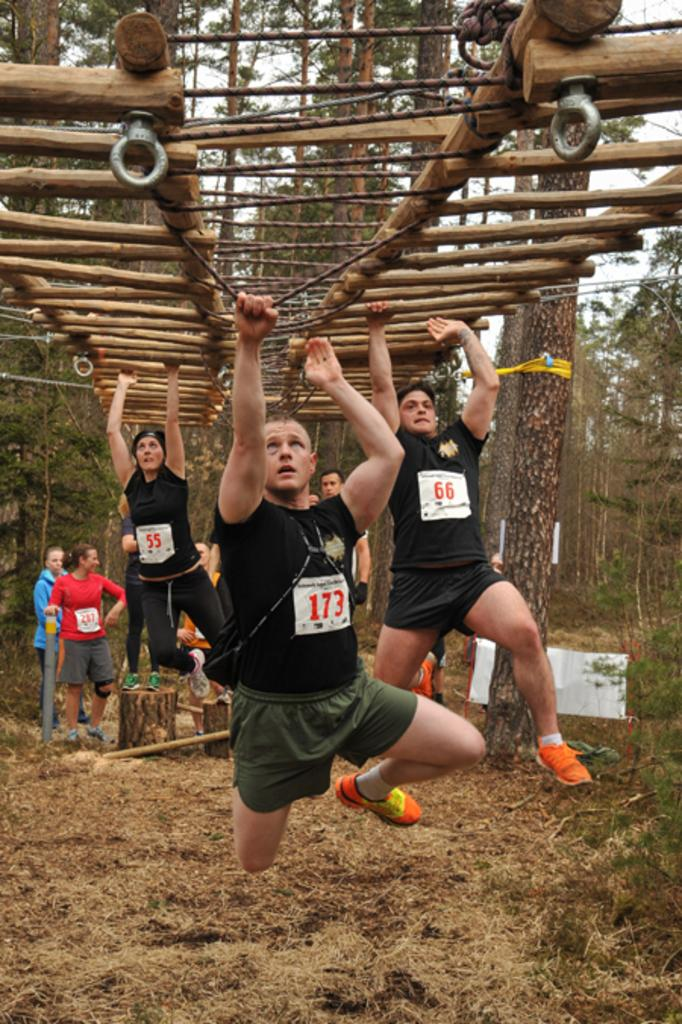<image>
Render a clear and concise summary of the photo. people competing in physical challenge of monkey bars wearing bibs with numbers 173 and 55 